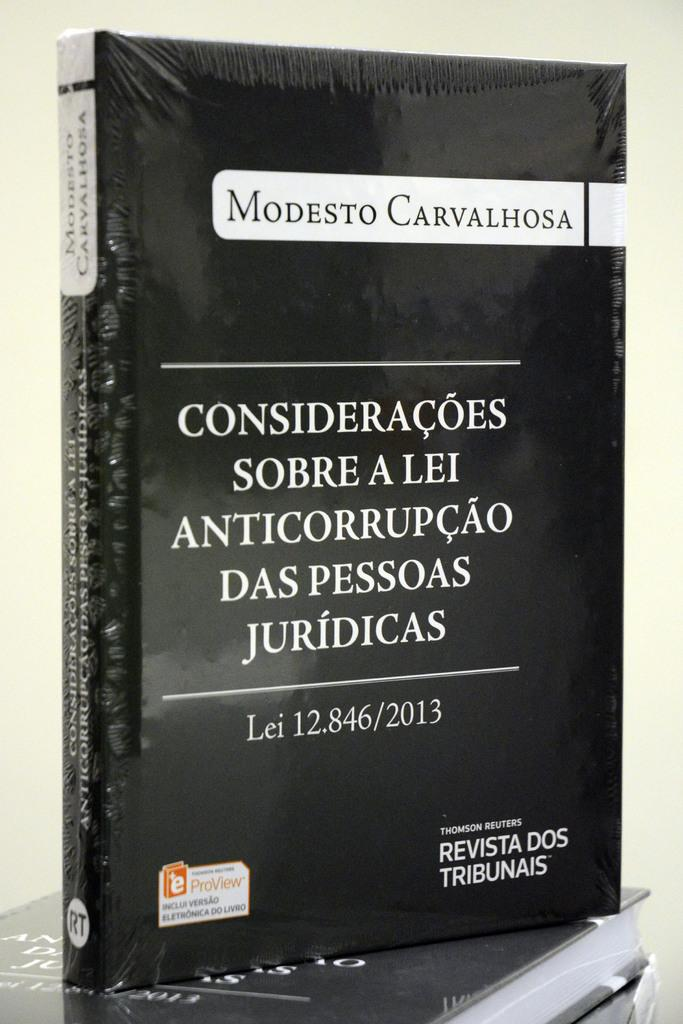<image>
Share a concise interpretation of the image provided. A book, wrapped in plastic, is titled Modesto Carvalhosa. 